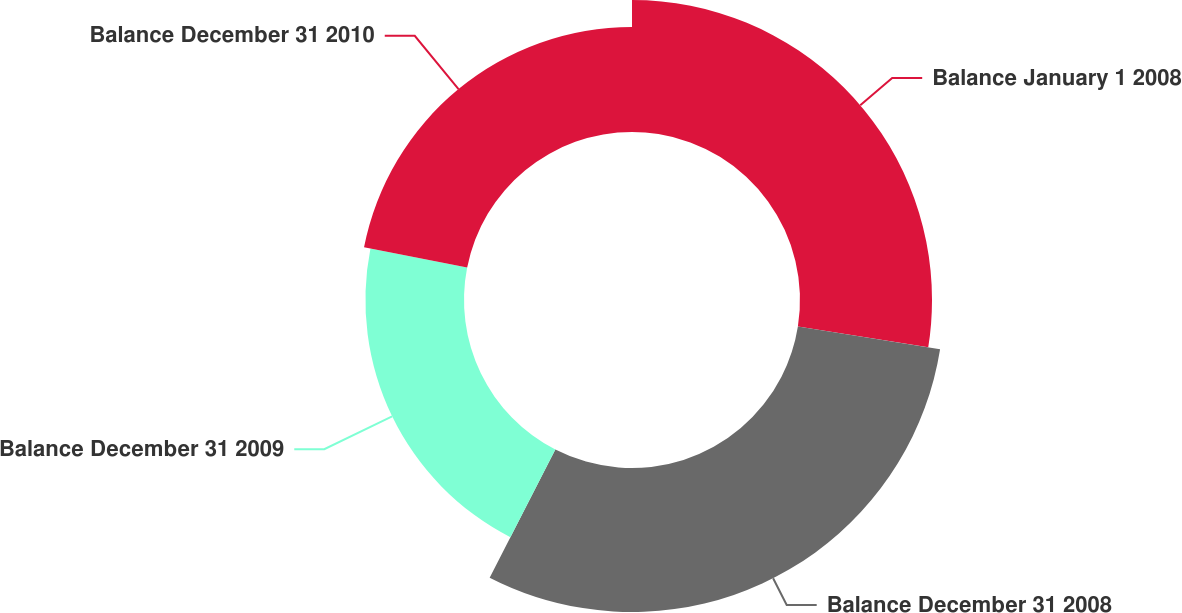Convert chart to OTSL. <chart><loc_0><loc_0><loc_500><loc_500><pie_chart><fcel>Balance January 1 2008<fcel>Balance December 31 2008<fcel>Balance December 31 2009<fcel>Balance December 31 2010<nl><fcel>27.52%<fcel>30.02%<fcel>20.55%<fcel>21.91%<nl></chart> 